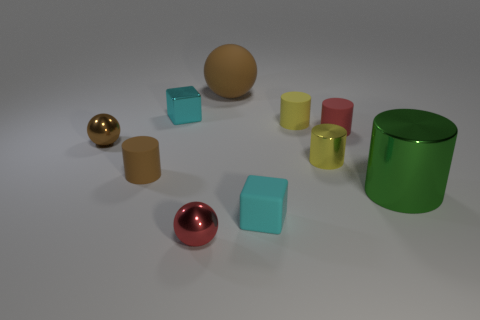Subtract all small brown balls. How many balls are left? 2 Subtract all brown cylinders. How many brown balls are left? 2 Subtract all yellow cylinders. How many cylinders are left? 3 Subtract 3 cylinders. How many cylinders are left? 2 Subtract all balls. How many objects are left? 7 Subtract all small purple spheres. Subtract all small spheres. How many objects are left? 8 Add 3 brown matte balls. How many brown matte balls are left? 4 Add 8 cyan metallic objects. How many cyan metallic objects exist? 9 Subtract 1 brown balls. How many objects are left? 9 Subtract all purple blocks. Subtract all red cylinders. How many blocks are left? 2 